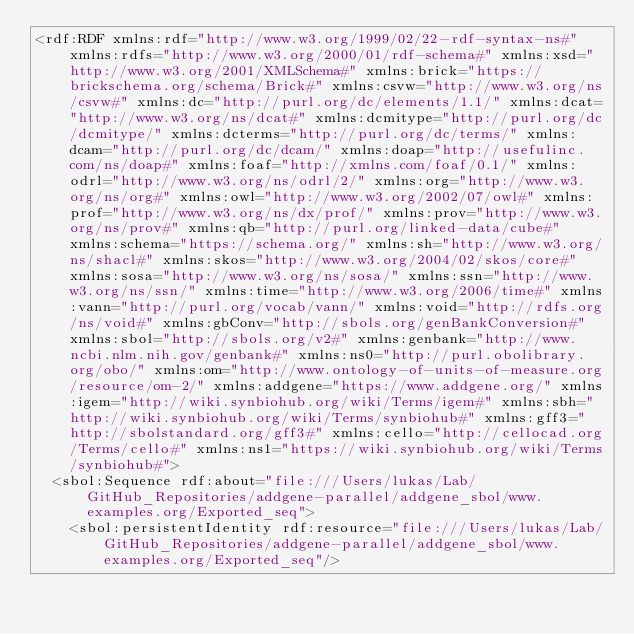<code> <loc_0><loc_0><loc_500><loc_500><_XML_><rdf:RDF xmlns:rdf="http://www.w3.org/1999/02/22-rdf-syntax-ns#" xmlns:rdfs="http://www.w3.org/2000/01/rdf-schema#" xmlns:xsd="http://www.w3.org/2001/XMLSchema#" xmlns:brick="https://brickschema.org/schema/Brick#" xmlns:csvw="http://www.w3.org/ns/csvw#" xmlns:dc="http://purl.org/dc/elements/1.1/" xmlns:dcat="http://www.w3.org/ns/dcat#" xmlns:dcmitype="http://purl.org/dc/dcmitype/" xmlns:dcterms="http://purl.org/dc/terms/" xmlns:dcam="http://purl.org/dc/dcam/" xmlns:doap="http://usefulinc.com/ns/doap#" xmlns:foaf="http://xmlns.com/foaf/0.1/" xmlns:odrl="http://www.w3.org/ns/odrl/2/" xmlns:org="http://www.w3.org/ns/org#" xmlns:owl="http://www.w3.org/2002/07/owl#" xmlns:prof="http://www.w3.org/ns/dx/prof/" xmlns:prov="http://www.w3.org/ns/prov#" xmlns:qb="http://purl.org/linked-data/cube#" xmlns:schema="https://schema.org/" xmlns:sh="http://www.w3.org/ns/shacl#" xmlns:skos="http://www.w3.org/2004/02/skos/core#" xmlns:sosa="http://www.w3.org/ns/sosa/" xmlns:ssn="http://www.w3.org/ns/ssn/" xmlns:time="http://www.w3.org/2006/time#" xmlns:vann="http://purl.org/vocab/vann/" xmlns:void="http://rdfs.org/ns/void#" xmlns:gbConv="http://sbols.org/genBankConversion#" xmlns:sbol="http://sbols.org/v2#" xmlns:genbank="http://www.ncbi.nlm.nih.gov/genbank#" xmlns:ns0="http://purl.obolibrary.org/obo/" xmlns:om="http://www.ontology-of-units-of-measure.org/resource/om-2/" xmlns:addgene="https://www.addgene.org/" xmlns:igem="http://wiki.synbiohub.org/wiki/Terms/igem#" xmlns:sbh="http://wiki.synbiohub.org/wiki/Terms/synbiohub#" xmlns:gff3="http://sbolstandard.org/gff3#" xmlns:cello="http://cellocad.org/Terms/cello#" xmlns:ns1="https://wiki.synbiohub.org/wiki/Terms/synbiohub#">
  <sbol:Sequence rdf:about="file:///Users/lukas/Lab/GitHub_Repositories/addgene-parallel/addgene_sbol/www.examples.org/Exported_seq">
    <sbol:persistentIdentity rdf:resource="file:///Users/lukas/Lab/GitHub_Repositories/addgene-parallel/addgene_sbol/www.examples.org/Exported_seq"/></code> 